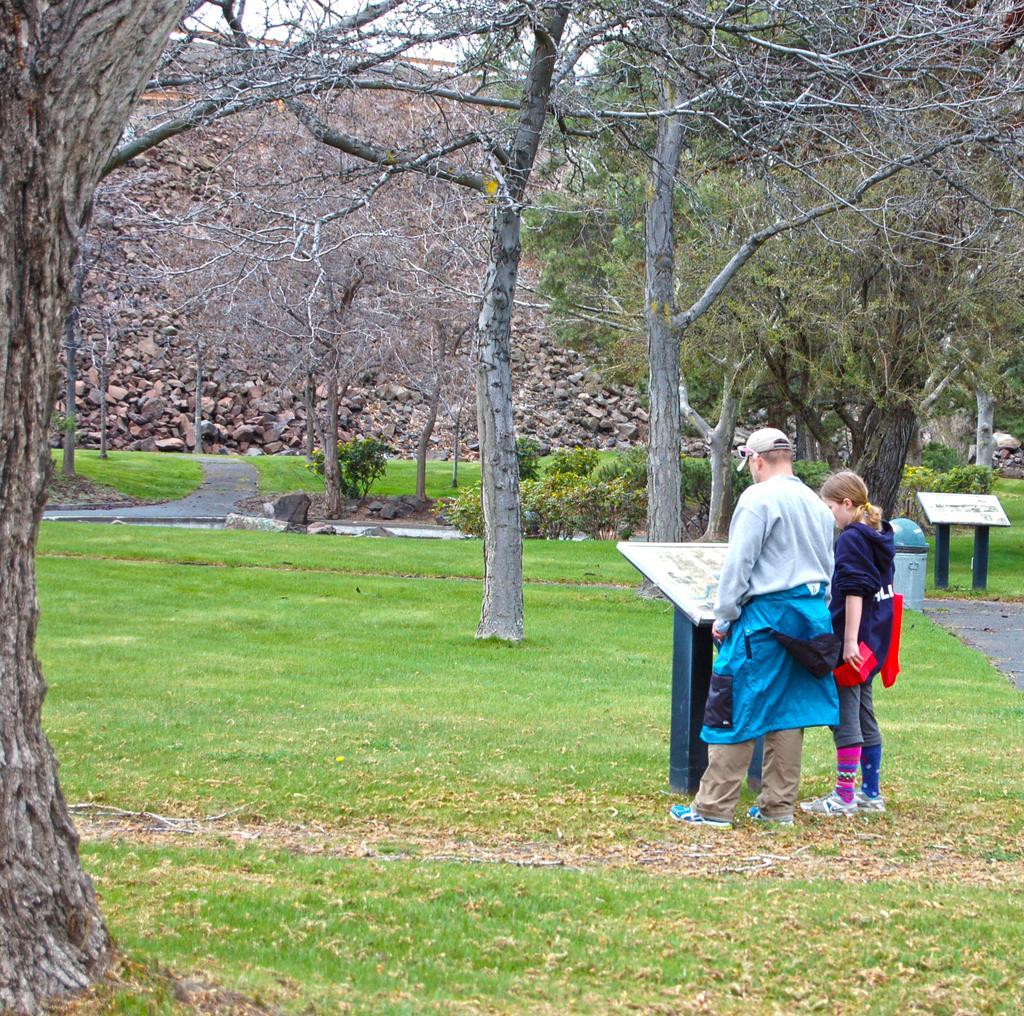Can you describe this image briefly? In the picture we can see a man and a girl standing on the grass surface near the desk on it we can see a white board and the man is wearing cap, in the background we can see a plants and trees. 